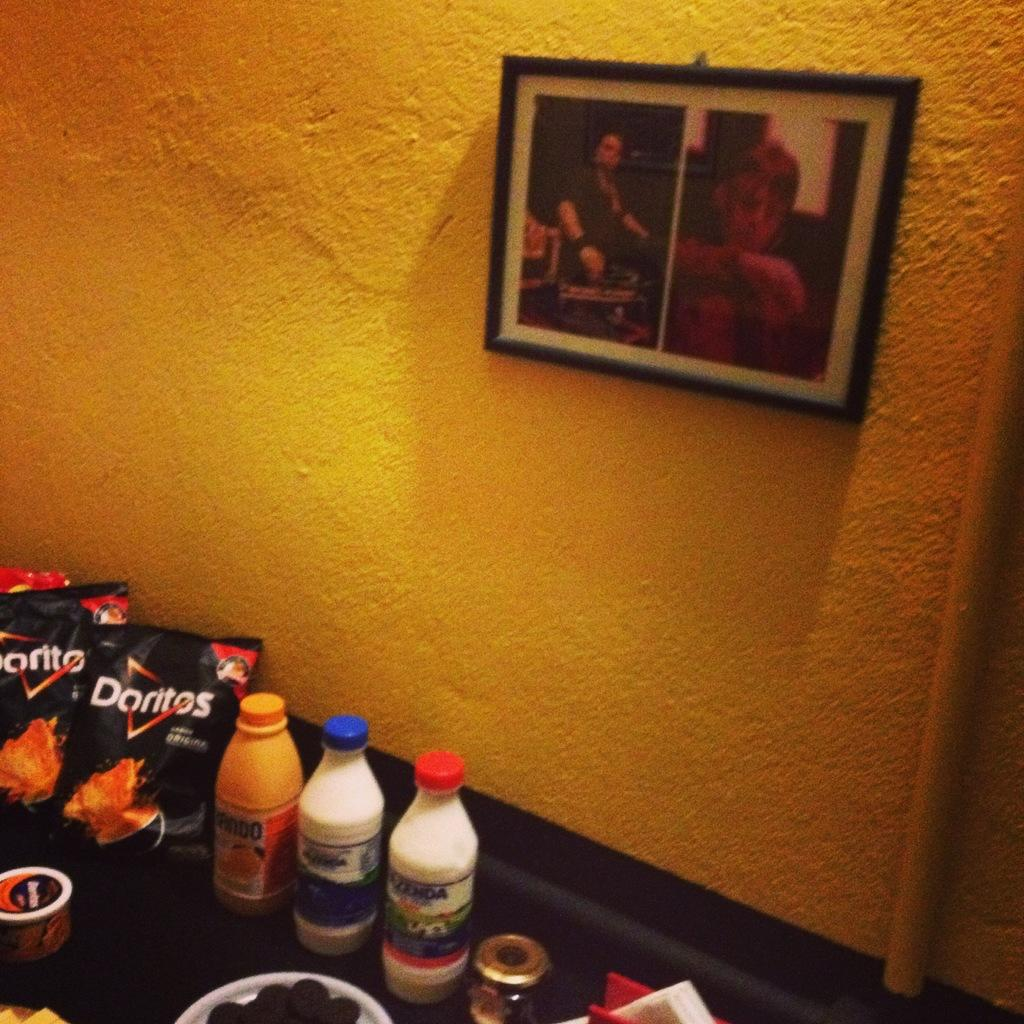<image>
Create a compact narrative representing the image presented. Bags of Doritos chips are displayed next to beverages on a table in front of a yellow wall. 